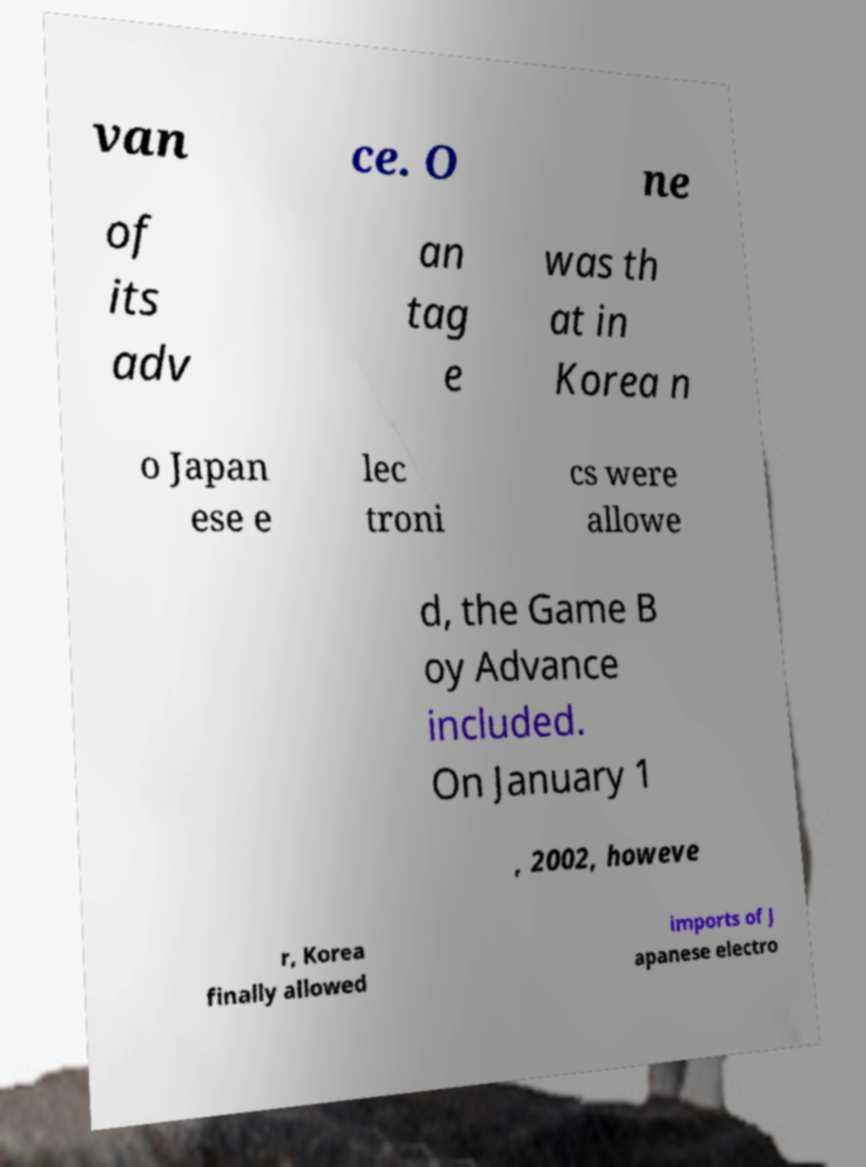Could you assist in decoding the text presented in this image and type it out clearly? van ce. O ne of its adv an tag e was th at in Korea n o Japan ese e lec troni cs were allowe d, the Game B oy Advance included. On January 1 , 2002, howeve r, Korea finally allowed imports of J apanese electro 